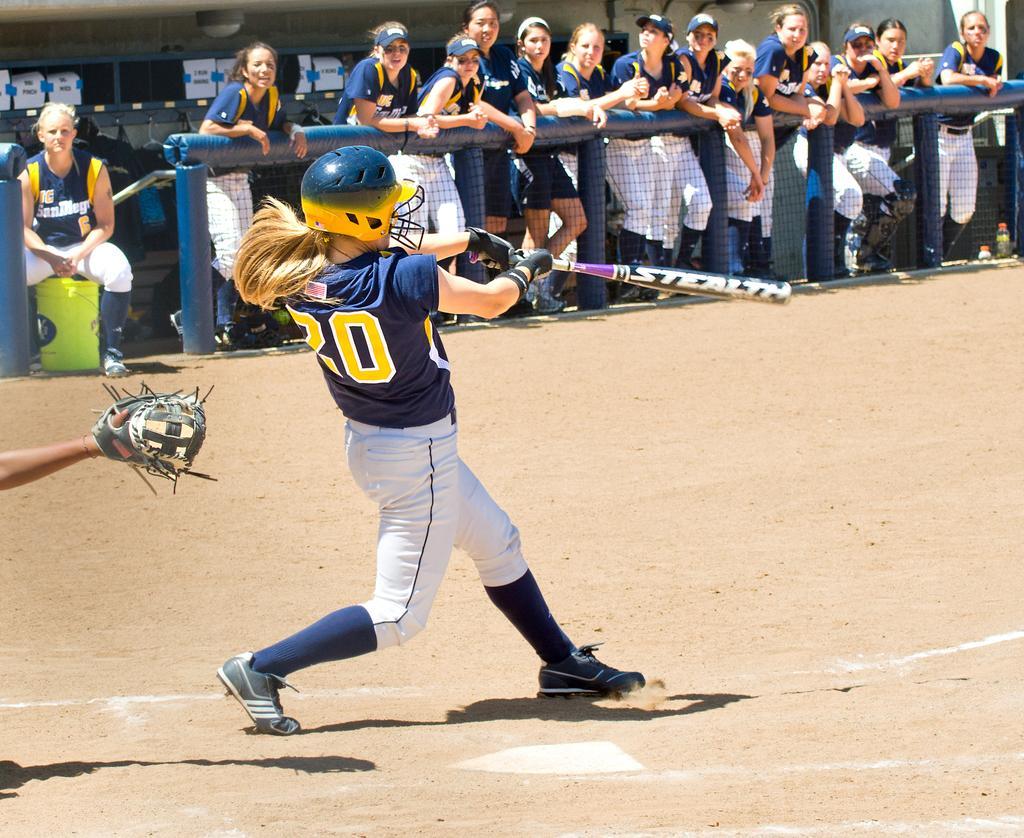Can you describe this image briefly? Here we can see a person holding a bat. In the background we can see group of people, mesh, and posters. 